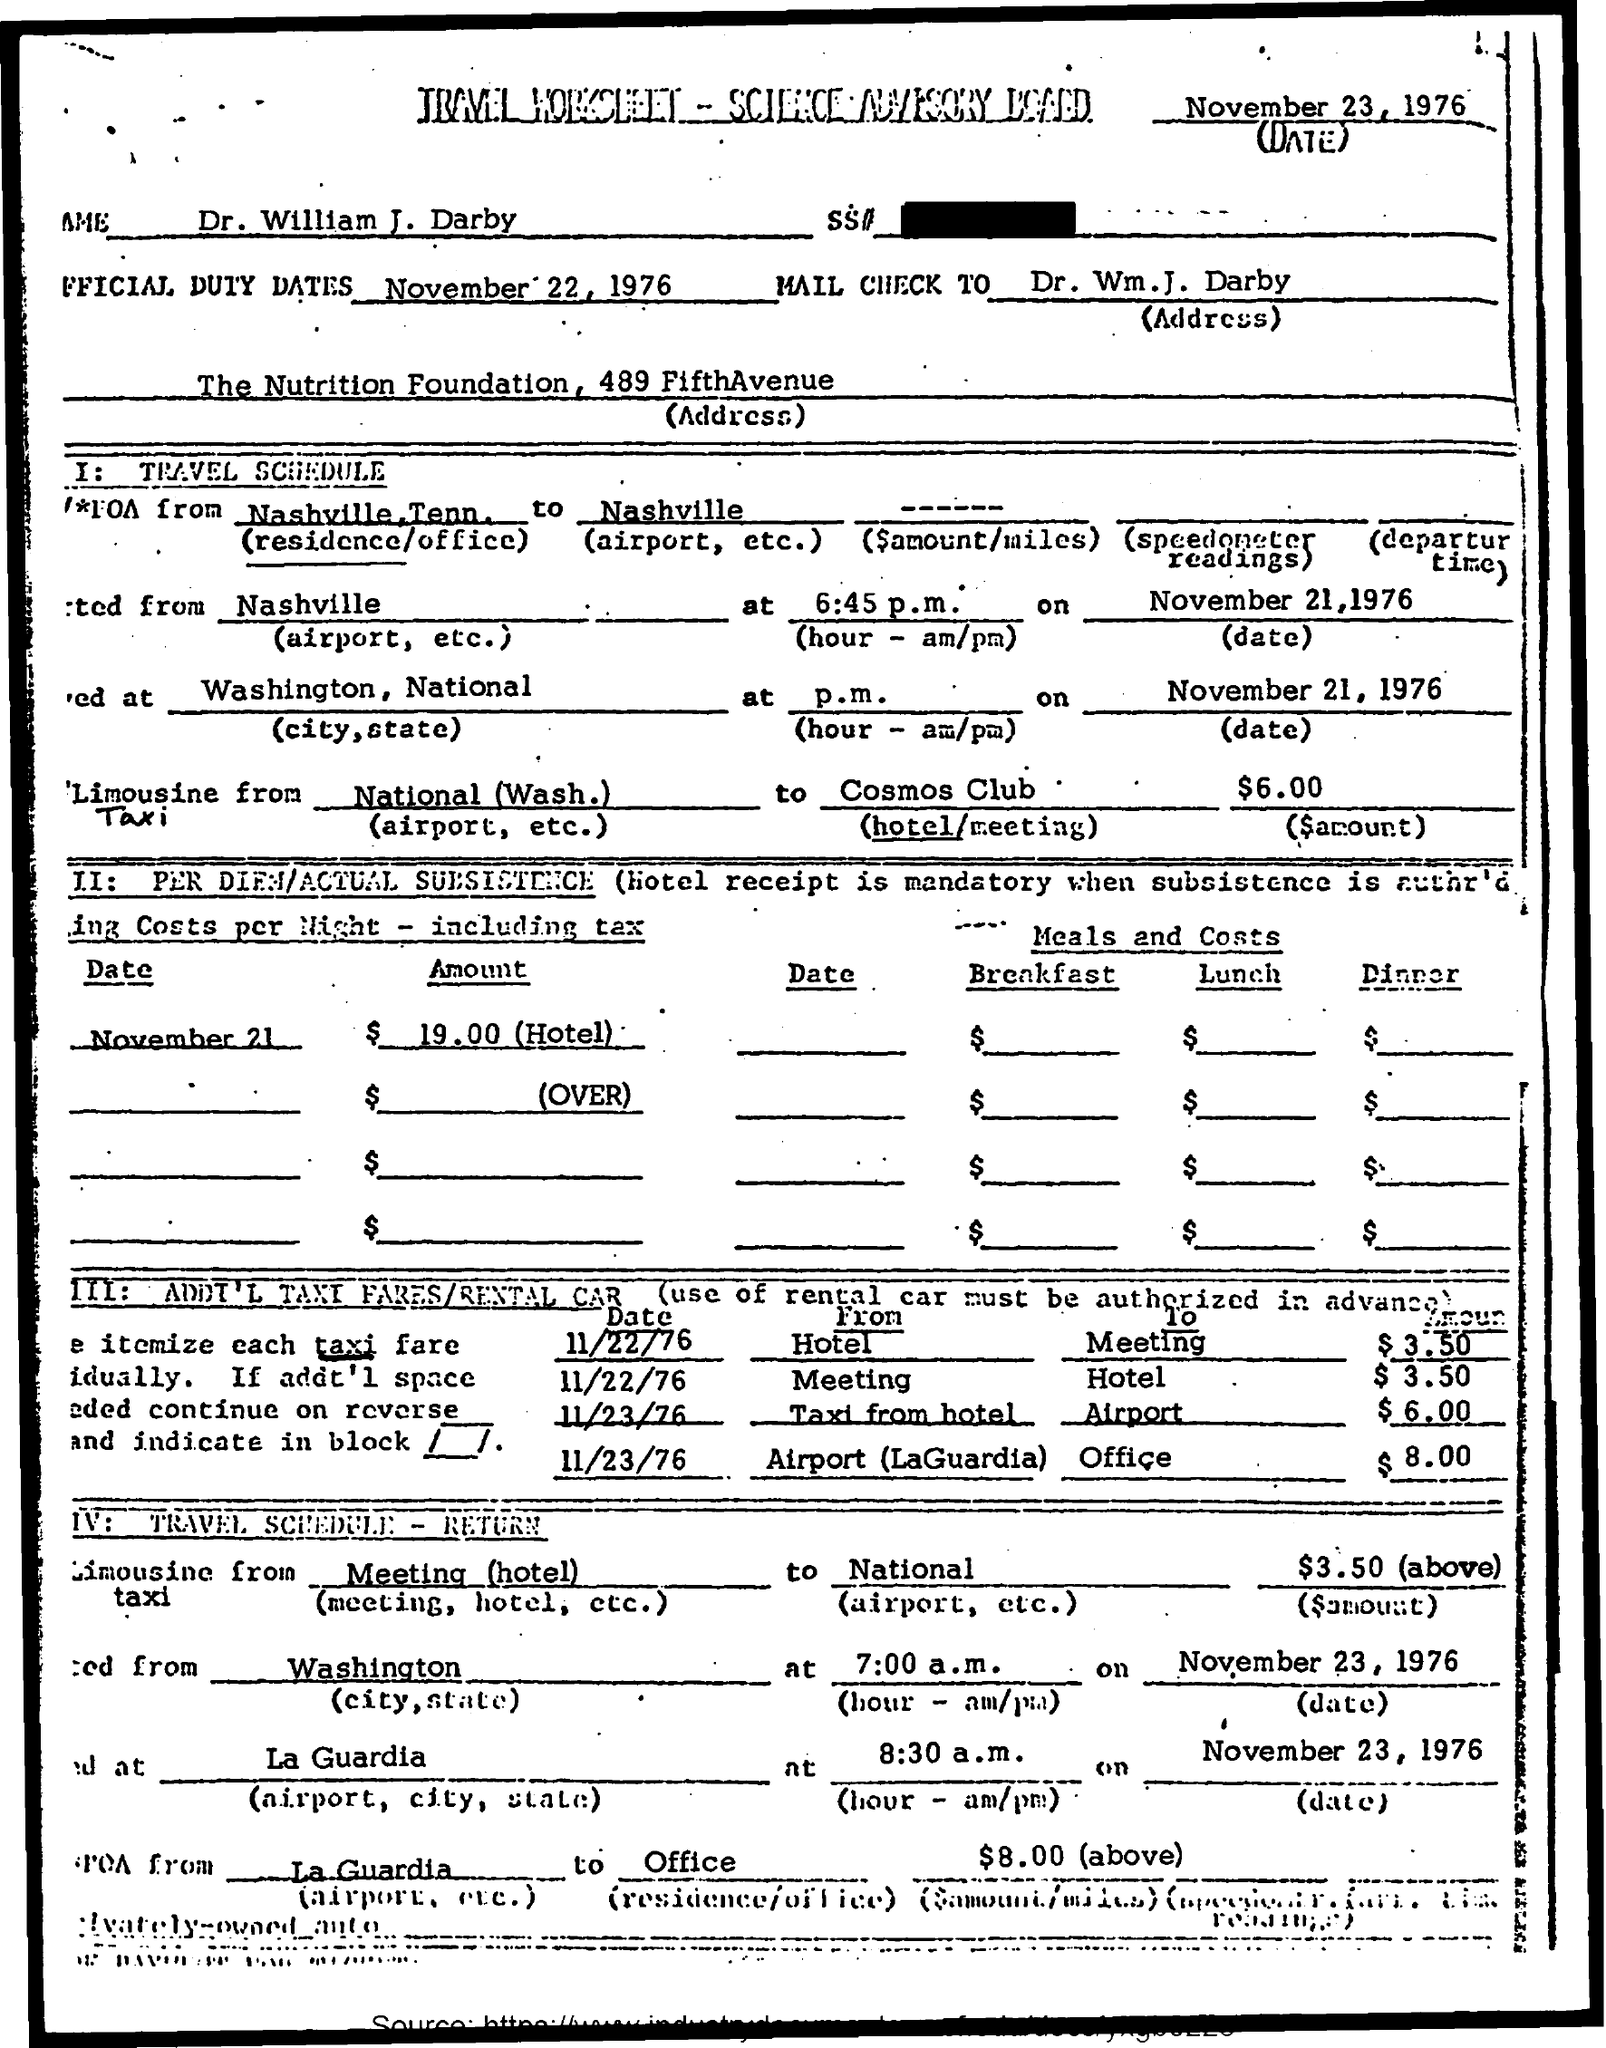What is the date mentioned ?
Provide a succinct answer. NOVEMBER 23, 1976. What is the name mentioned ?
Provide a short and direct response. DR. WILLIAM J. DARBY. What is the official duty dates mentioned ?
Ensure brevity in your answer.  November 22, 1976. 